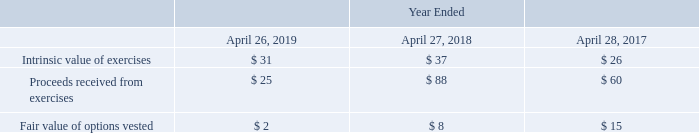Stock Options
Additional information related to our stock options is summarized below (in millions):
Which years does the table provide Additional information related to the company's stock options? 2019, 2018, 2017. What was the intrinsic value of exercises in 2019?
Answer scale should be: million. 31. What were the Proceeds received from exercises in 2018?
Answer scale should be: million. 88. What was the change in Intrinsic value of exercises between 2017 and 2018?
Answer scale should be: million. 37-26
Answer: 11. How many years did Proceeds received from exercises exceed $50 million? 2018##2017
Answer: 2. What was the percentage change in the Fair value of options vested between 2018 and 2019?
Answer scale should be: percent. (2-8)/8
Answer: -75. 